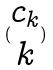Convert formula to latex. <formula><loc_0><loc_0><loc_500><loc_500>( \begin{matrix} c _ { k } \\ k \end{matrix} )</formula> 